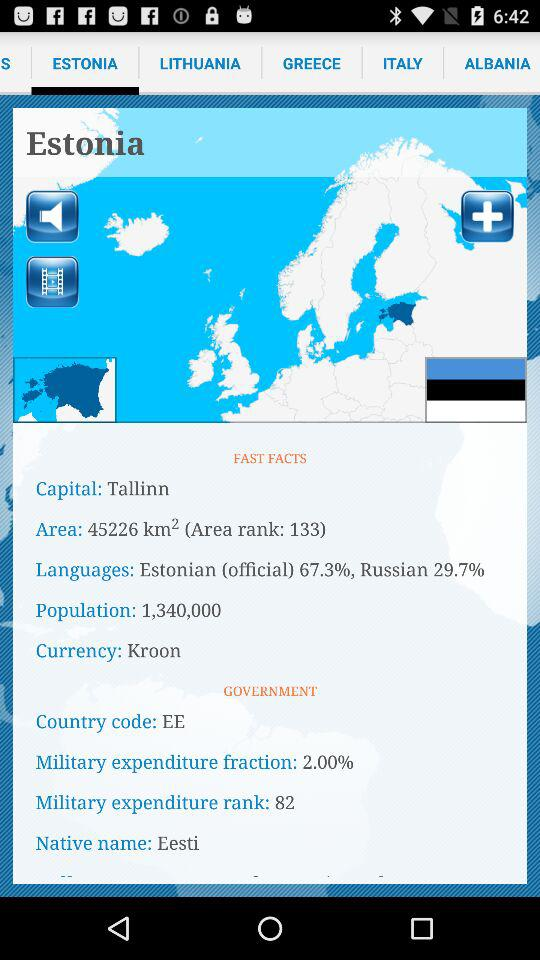What is the military's expenditure rank? The military's expenditure rank is 82. 